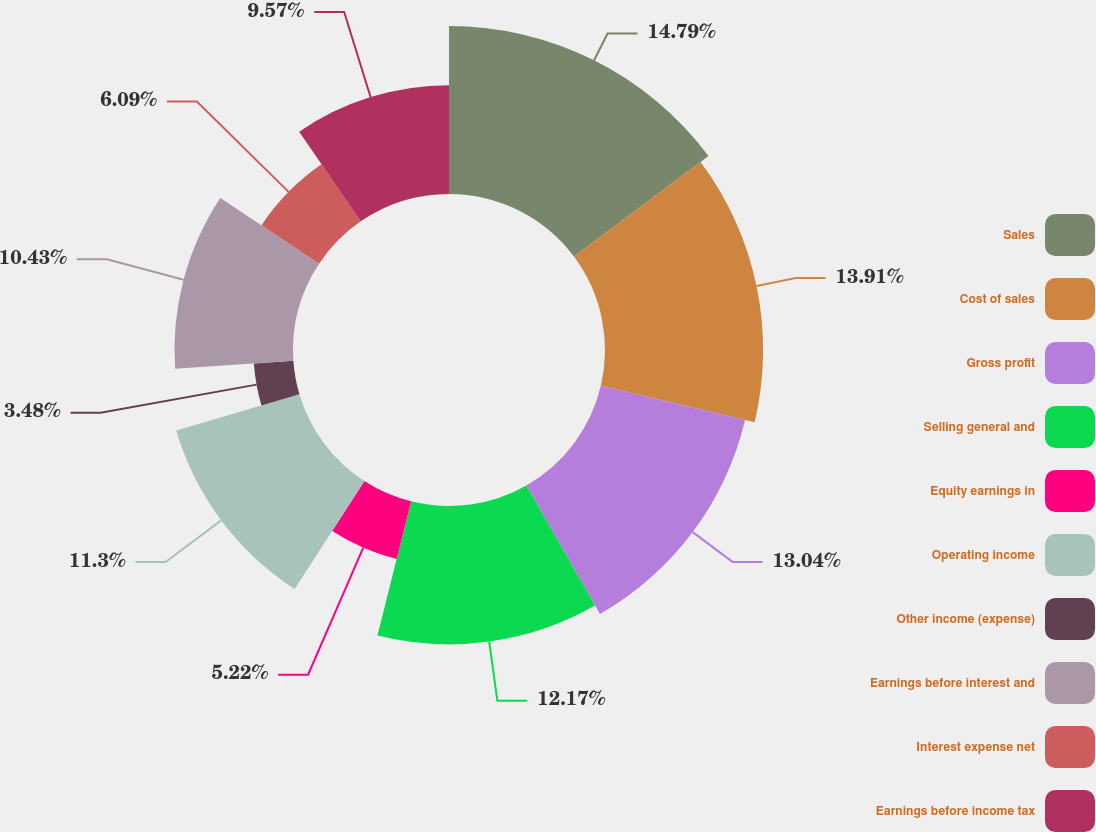Convert chart to OTSL. <chart><loc_0><loc_0><loc_500><loc_500><pie_chart><fcel>Sales<fcel>Cost of sales<fcel>Gross profit<fcel>Selling general and<fcel>Equity earnings in<fcel>Operating income<fcel>Other income (expense)<fcel>Earnings before interest and<fcel>Interest expense net<fcel>Earnings before income tax<nl><fcel>14.78%<fcel>13.91%<fcel>13.04%<fcel>12.17%<fcel>5.22%<fcel>11.3%<fcel>3.48%<fcel>10.43%<fcel>6.09%<fcel>9.57%<nl></chart> 